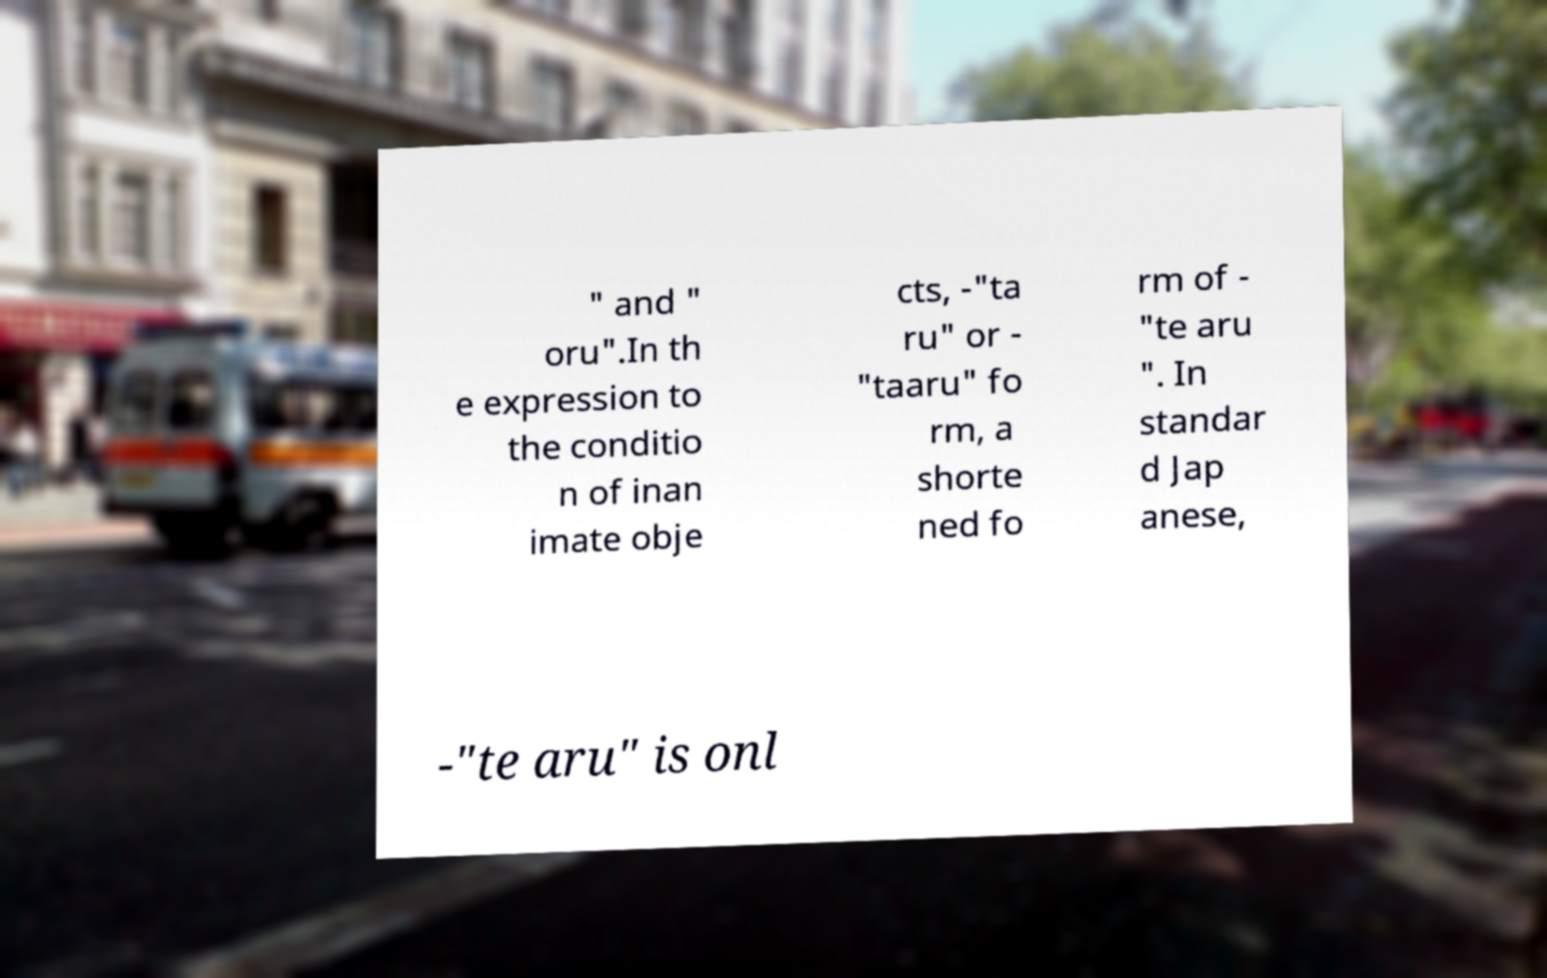Can you accurately transcribe the text from the provided image for me? " and " oru".In th e expression to the conditio n of inan imate obje cts, -"ta ru" or - "taaru" fo rm, a shorte ned fo rm of - "te aru ". In standar d Jap anese, -"te aru" is onl 